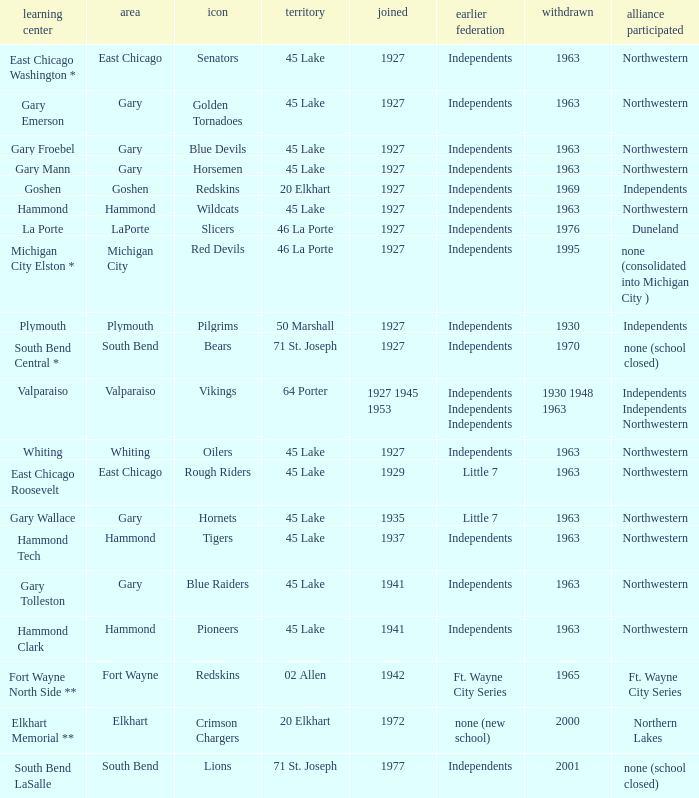When doeas Mascot of blue devils in Gary Froebel School? 1927.0. 